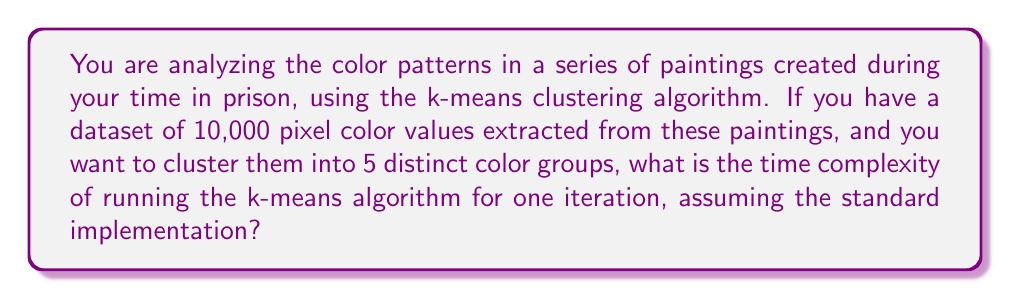Show me your answer to this math problem. To understand the time complexity of the k-means algorithm for one iteration, let's break down the steps:

1. Let $n$ be the number of data points (pixel color values) and $k$ be the number of clusters.

2. In this case, $n = 10,000$ and $k = 5$.

3. For each iteration of the k-means algorithm:

   a. Assign each data point to the nearest centroid:
      - This requires calculating the distance between each data point and each centroid.
      - For each data point, we perform $k$ distance calculations.
      - Total operations: $O(nk)$

   b. Recalculate the centroids:
      - For each cluster, we need to calculate the mean of all points assigned to it.
      - This requires summing up all points in each cluster and dividing by the number of points.
      - Total operations: $O(n)$

4. The total time complexity for one iteration is the sum of these two steps:

   $$O(nk) + O(n) = O(nk)$$

5. Since $k$ is typically much smaller than $n$, and in this case $k$ is fixed at 5, we can consider it a constant.

6. Therefore, the time complexity simplifies to $O(n)$ for one iteration of the k-means algorithm in this specific scenario.

It's important to note that this is for a single iteration. The total runtime of the algorithm depends on the number of iterations until convergence, which can vary based on the data and initialization.
Answer: $O(n)$, where $n$ is the number of pixel color values (10,000 in this case). 